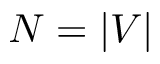<formula> <loc_0><loc_0><loc_500><loc_500>N = | V |</formula> 